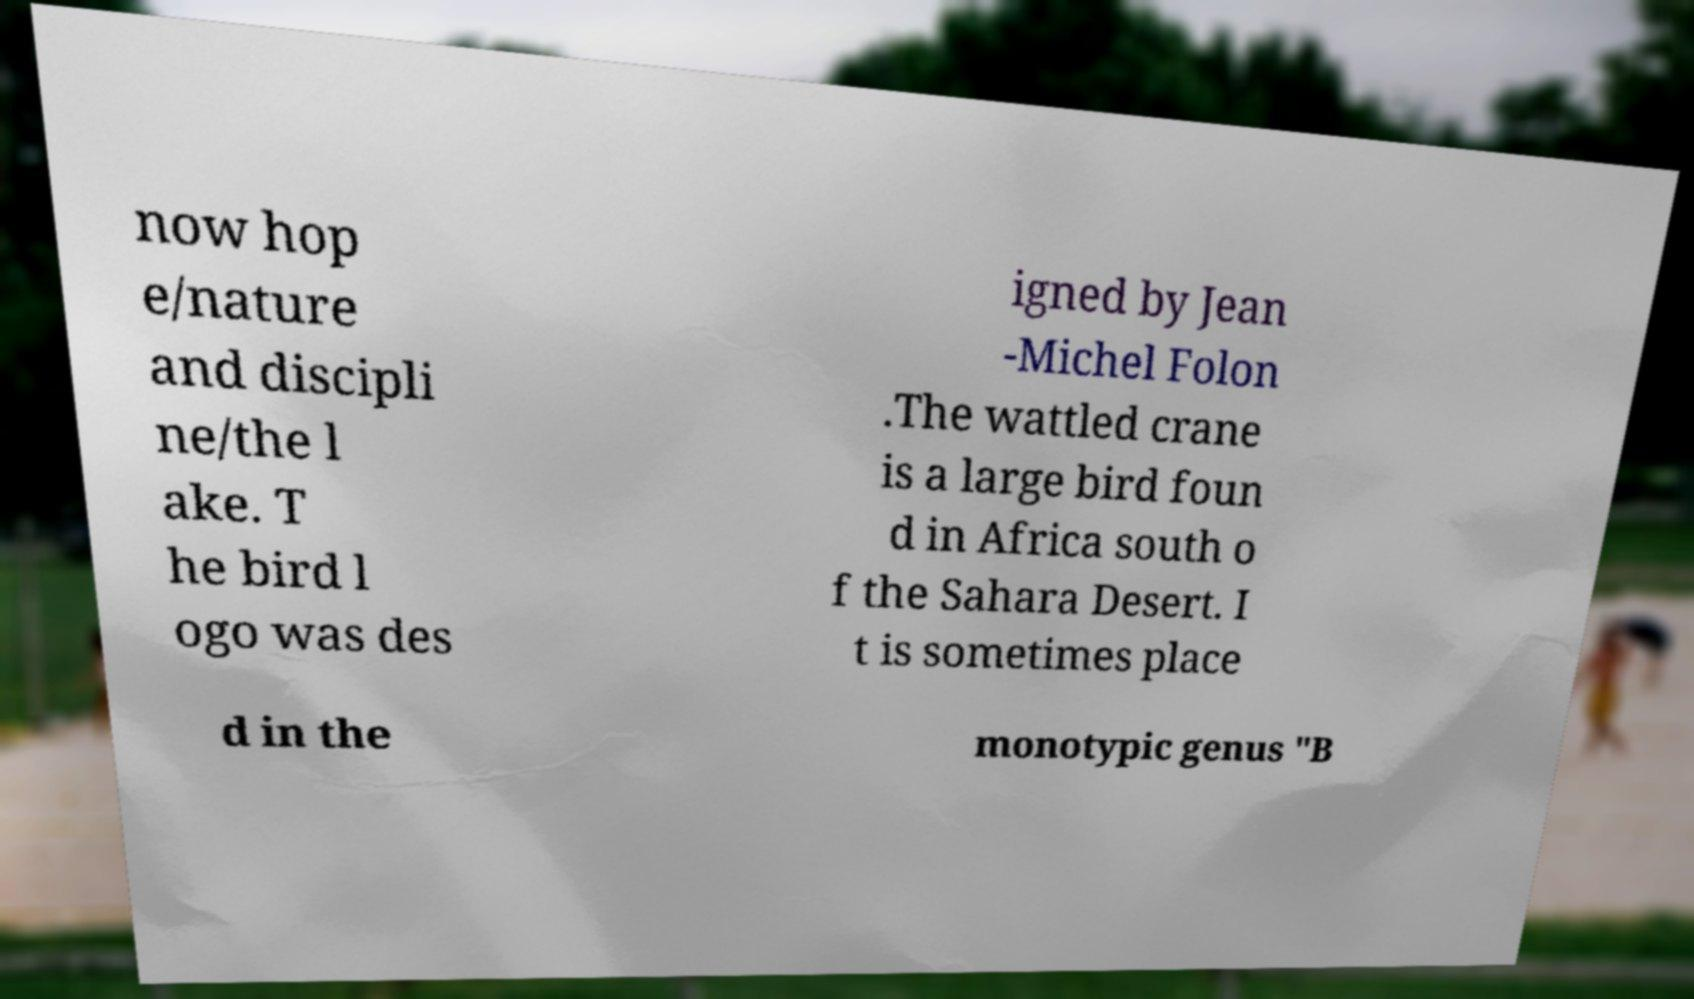Can you accurately transcribe the text from the provided image for me? now hop e/nature and discipli ne/the l ake. T he bird l ogo was des igned by Jean -Michel Folon .The wattled crane is a large bird foun d in Africa south o f the Sahara Desert. I t is sometimes place d in the monotypic genus "B 